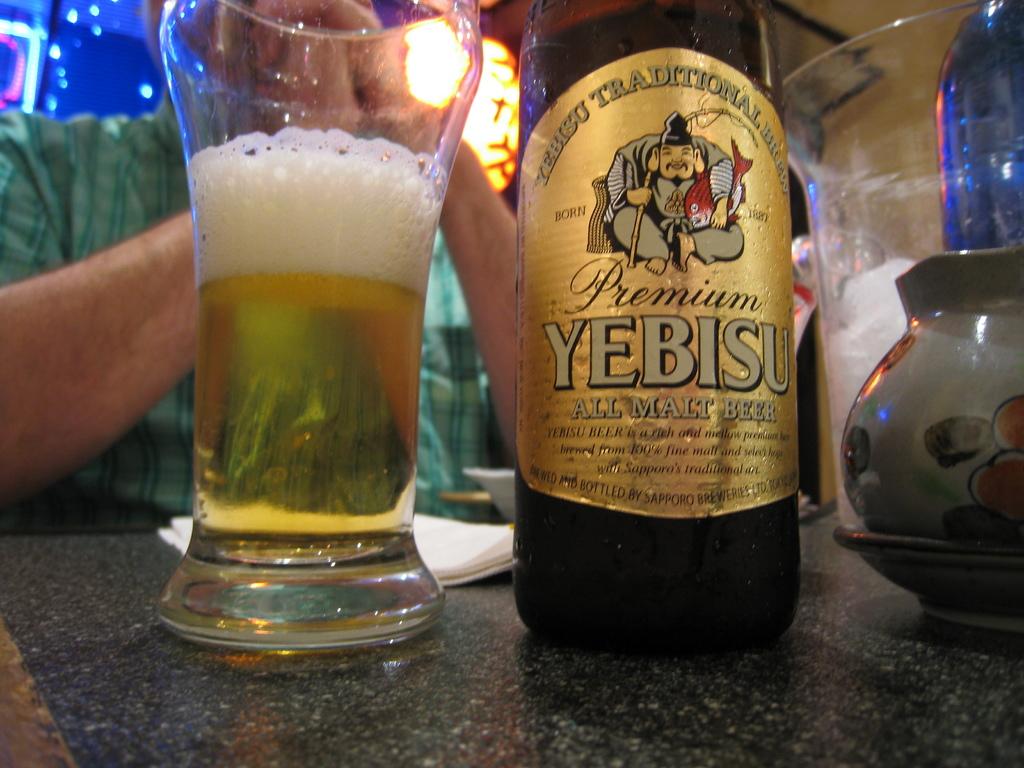Is this beer premium or no?
Make the answer very short. Yes. 